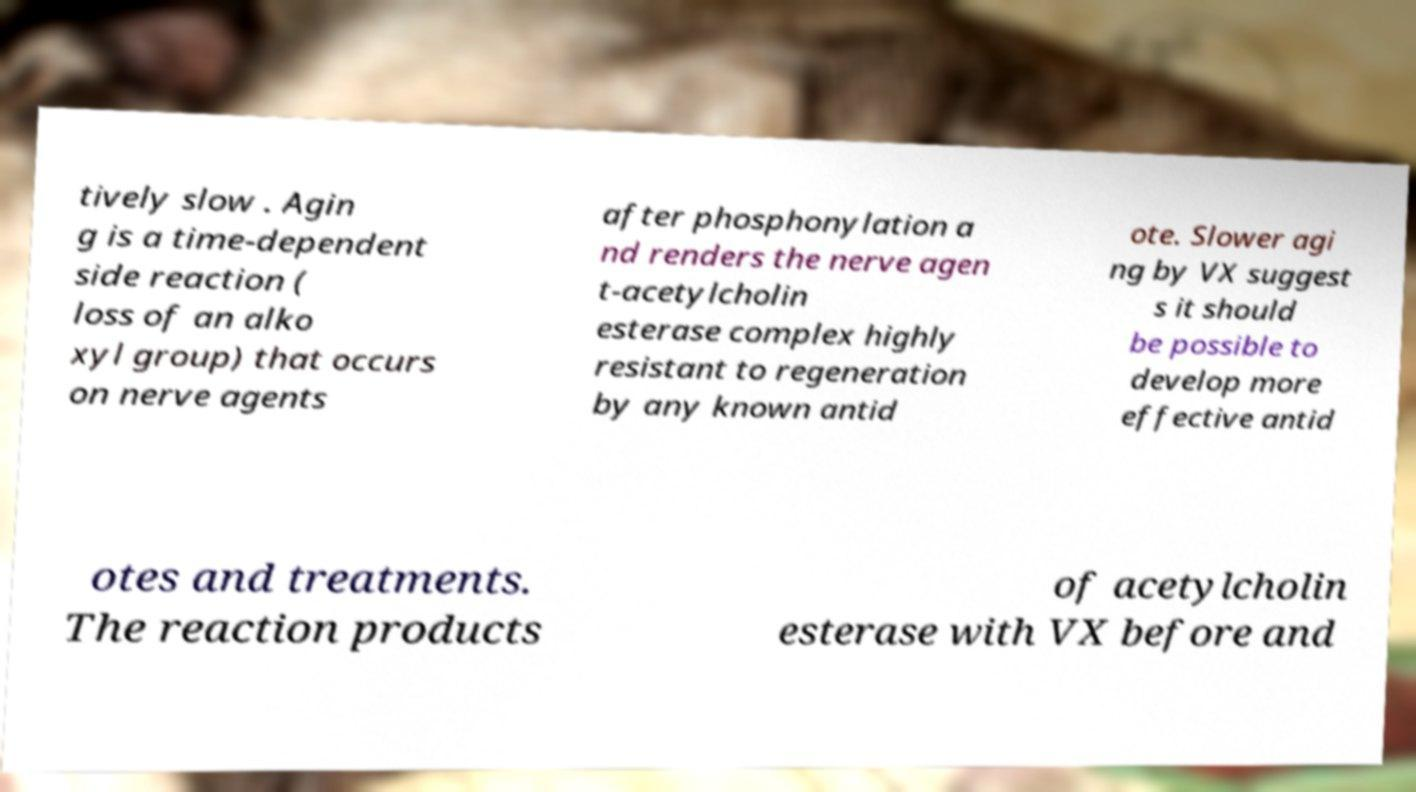For documentation purposes, I need the text within this image transcribed. Could you provide that? tively slow . Agin g is a time-dependent side reaction ( loss of an alko xyl group) that occurs on nerve agents after phosphonylation a nd renders the nerve agen t-acetylcholin esterase complex highly resistant to regeneration by any known antid ote. Slower agi ng by VX suggest s it should be possible to develop more effective antid otes and treatments. The reaction products of acetylcholin esterase with VX before and 